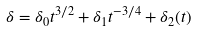Convert formula to latex. <formula><loc_0><loc_0><loc_500><loc_500>\delta = \delta _ { 0 } t ^ { 3 / 2 } + \delta _ { 1 } t ^ { - 3 / 4 } + \delta _ { 2 } ( t )</formula> 